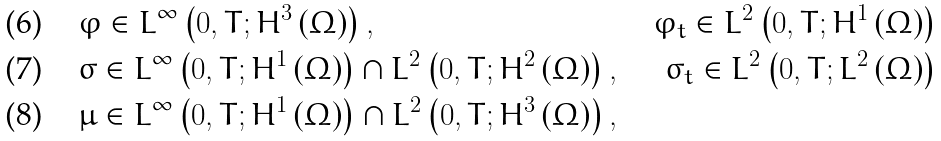Convert formula to latex. <formula><loc_0><loc_0><loc_500><loc_500>& \varphi \in L ^ { \infty } \left ( 0 , T ; H ^ { 3 } \left ( \Omega \right ) \right ) , & \varphi _ { t } \in L ^ { 2 } \left ( 0 , T ; H ^ { 1 } \left ( \Omega \right ) \right ) \\ & \sigma \in L ^ { \infty } \left ( 0 , T ; H ^ { 1 } \left ( \Omega \right ) \right ) \cap L ^ { 2 } \left ( 0 , T ; H ^ { 2 } \left ( \Omega \right ) \right ) , & \sigma _ { t } \in L ^ { 2 } \left ( 0 , T ; L ^ { 2 } \left ( \Omega \right ) \right ) \\ & \mu \in L ^ { \infty } \left ( 0 , T ; H ^ { 1 } \left ( \Omega \right ) \right ) \cap L ^ { 2 } \left ( 0 , T ; H ^ { 3 } \left ( \Omega \right ) \right ) ,</formula> 